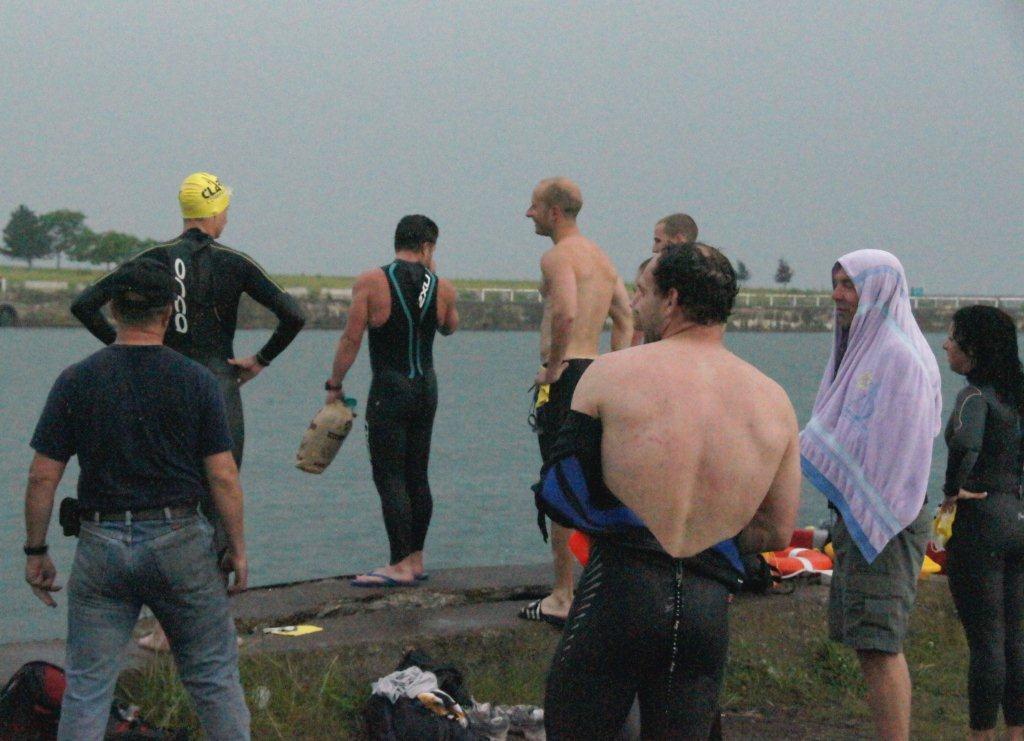Could you give a brief overview of what you see in this image? There are few and a woman on the right are standing on the ground and among them one man is holding an object in his hand and another person covered his half body with a towel. In the background there is water,trees and sky. At the bottom there are clothes and some other items on the ground. 